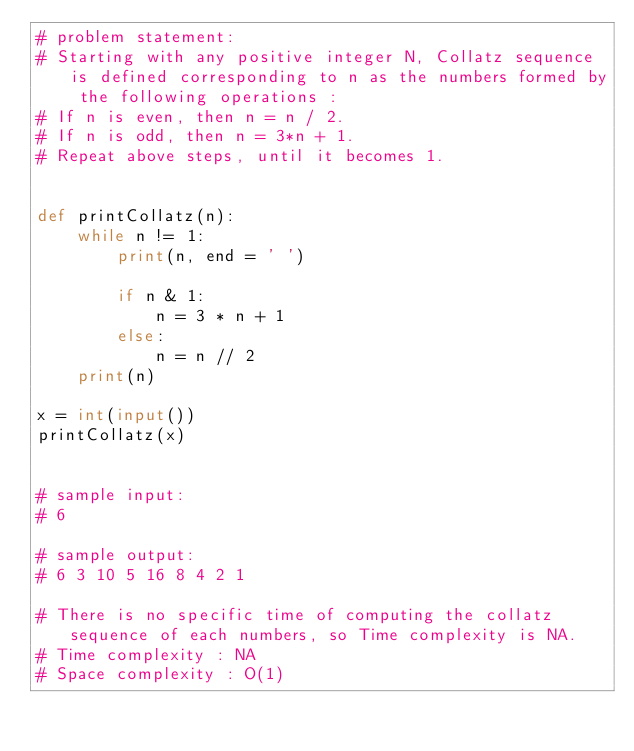<code> <loc_0><loc_0><loc_500><loc_500><_Python_># problem statement: 
# Starting with any positive integer N, Collatz sequence is defined corresponding to n as the numbers formed by the following operations :
# If n is even, then n = n / 2.
# If n is odd, then n = 3*n + 1.
# Repeat above steps, until it becomes 1.


def printCollatz(n): 
    while n != 1: 
        print(n, end = ' ') 

        if n & 1: 
            n = 3 * n + 1 
        else: 
            n = n // 2  
    print(n) 

x = int(input()) 
printCollatz(x) 


# sample input: 
# 6

# sample output:
# 6 3 10 5 16 8 4 2 1

# There is no specific time of computing the collatz sequence of each numbers, so Time complexity is NA.
# Time complexity : NA
# Space complexity : O(1)</code> 